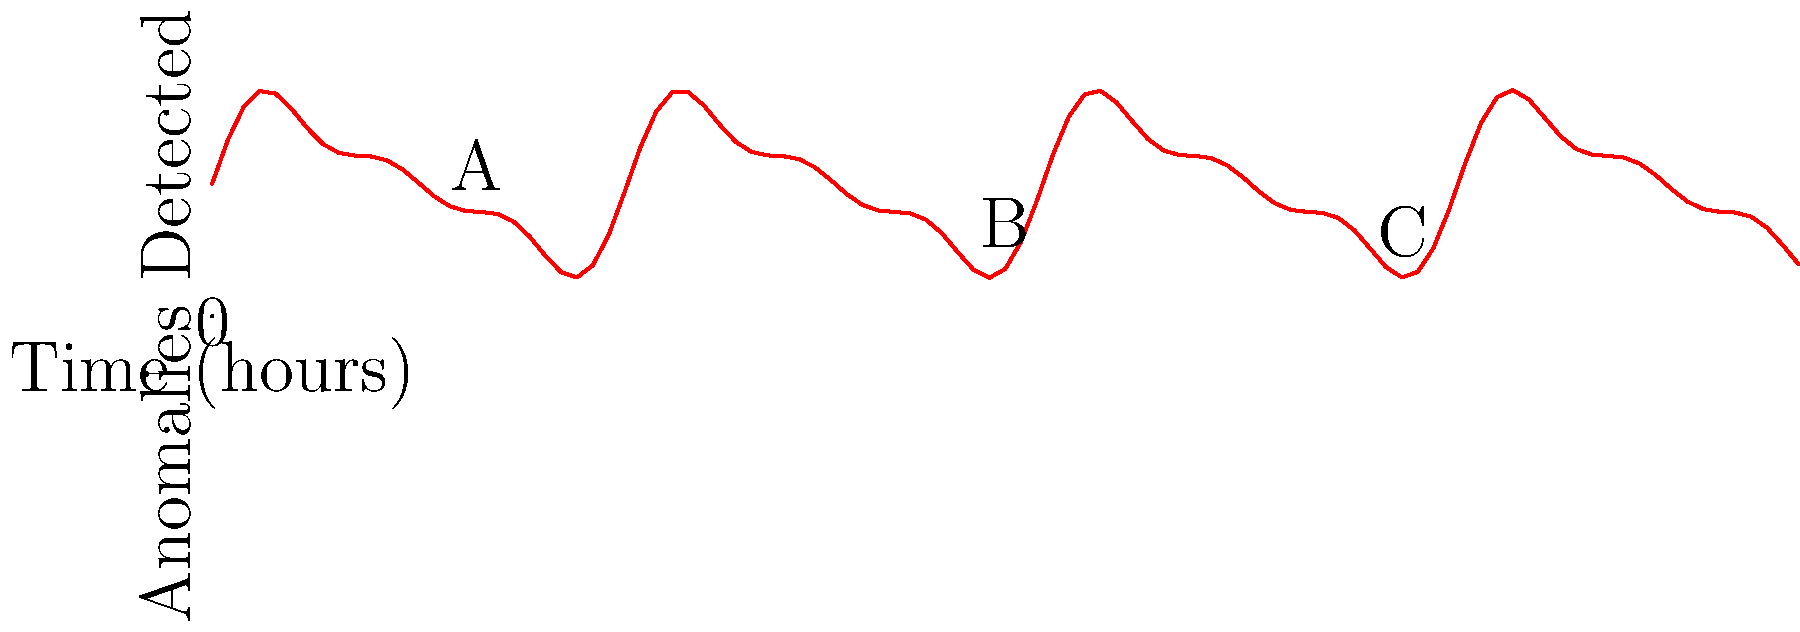Based on the graph showing detected anomalies over a 24-hour period during a cybersecurity breach, at which point (A, B, or C) did the breach likely begin, and why? To determine when the breach likely began, we need to analyze the graph and consider the typical pattern of a cybersecurity breach:

1. The graph shows anomalies detected over a 24-hour period.
2. Point A (around 4 hours) shows a sudden increase in anomalies.
3. Point B (around 12 hours) represents a peak in anomalies detected.
4. Point C (around 18 hours) shows a decline in anomalies.

5. In a typical cybersecurity breach:
   - The initial breach often causes a sudden spike in anomalies as the attacker gains access.
   - Anomaly detections usually increase as the attacker expands their presence.
   - Eventually, anomalies may decrease as the attacker becomes more stealthy or starts data exfiltration.

6. Given this pattern, Point A is the most likely beginning of the breach because:
   - It shows a sudden increase in anomalies, indicating the initial unauthorized access.
   - It occurs before the peak (Point B), allowing time for the breach to expand.
   - The pattern after Point A follows the typical progression of a cybersecurity breach.

Therefore, the breach likely began at Point A, around 4 hours into the monitored period.
Answer: Point A 